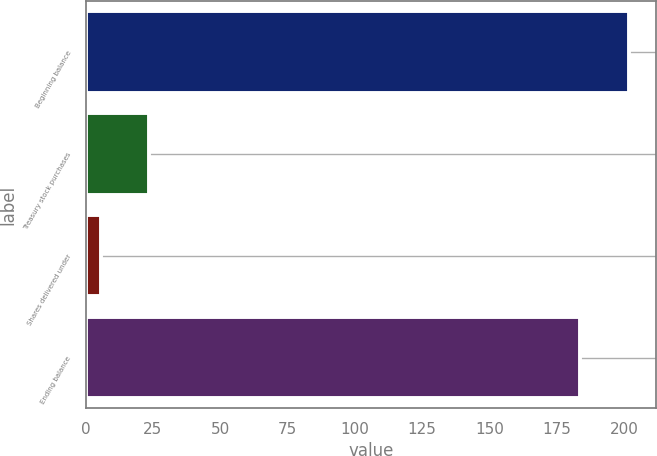Convert chart. <chart><loc_0><loc_0><loc_500><loc_500><bar_chart><fcel>Beginning balance<fcel>Treasury stock purchases<fcel>Shares delivered under<fcel>Ending balance<nl><fcel>201.79<fcel>23.69<fcel>5.7<fcel>183.8<nl></chart> 